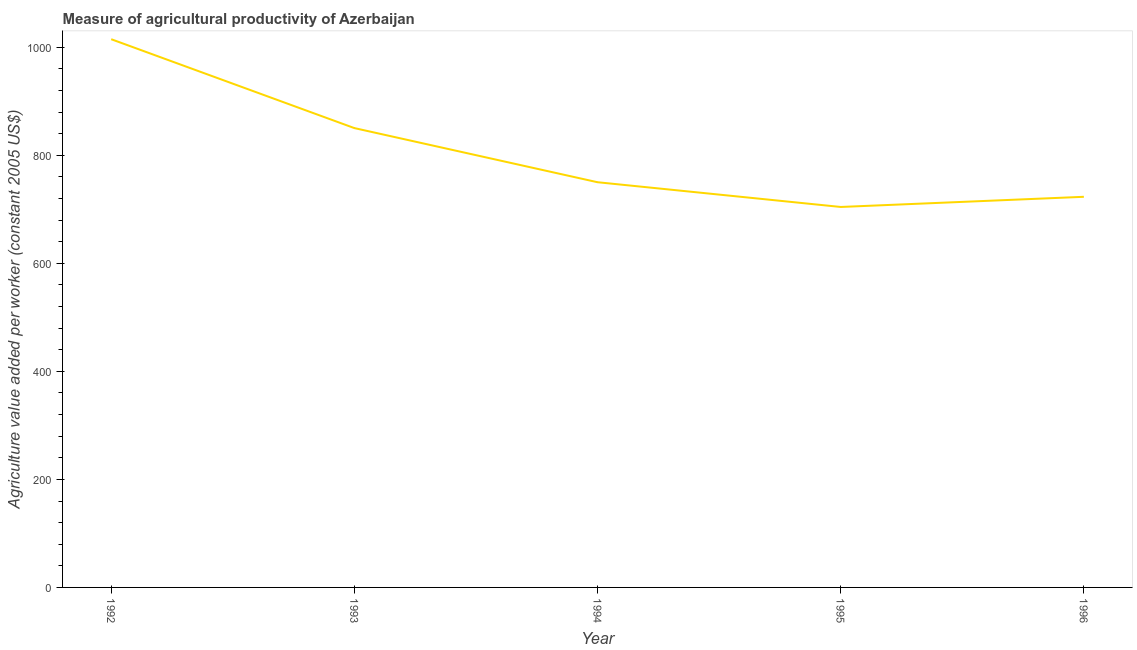What is the agriculture value added per worker in 1994?
Keep it short and to the point. 750.16. Across all years, what is the maximum agriculture value added per worker?
Offer a terse response. 1014.91. Across all years, what is the minimum agriculture value added per worker?
Make the answer very short. 704.35. What is the sum of the agriculture value added per worker?
Make the answer very short. 4042.96. What is the difference between the agriculture value added per worker in 1993 and 1995?
Your answer should be compact. 146.02. What is the average agriculture value added per worker per year?
Offer a terse response. 808.59. What is the median agriculture value added per worker?
Offer a terse response. 750.16. What is the ratio of the agriculture value added per worker in 1993 to that in 1996?
Provide a succinct answer. 1.18. What is the difference between the highest and the second highest agriculture value added per worker?
Ensure brevity in your answer.  164.54. Is the sum of the agriculture value added per worker in 1993 and 1995 greater than the maximum agriculture value added per worker across all years?
Ensure brevity in your answer.  Yes. What is the difference between the highest and the lowest agriculture value added per worker?
Provide a short and direct response. 310.56. In how many years, is the agriculture value added per worker greater than the average agriculture value added per worker taken over all years?
Offer a terse response. 2. Does the agriculture value added per worker monotonically increase over the years?
Keep it short and to the point. No. How many lines are there?
Make the answer very short. 1. Are the values on the major ticks of Y-axis written in scientific E-notation?
Give a very brief answer. No. Does the graph contain any zero values?
Give a very brief answer. No. Does the graph contain grids?
Your response must be concise. No. What is the title of the graph?
Provide a short and direct response. Measure of agricultural productivity of Azerbaijan. What is the label or title of the X-axis?
Keep it short and to the point. Year. What is the label or title of the Y-axis?
Your answer should be compact. Agriculture value added per worker (constant 2005 US$). What is the Agriculture value added per worker (constant 2005 US$) in 1992?
Your answer should be compact. 1014.91. What is the Agriculture value added per worker (constant 2005 US$) of 1993?
Give a very brief answer. 850.37. What is the Agriculture value added per worker (constant 2005 US$) of 1994?
Provide a succinct answer. 750.16. What is the Agriculture value added per worker (constant 2005 US$) in 1995?
Offer a terse response. 704.35. What is the Agriculture value added per worker (constant 2005 US$) in 1996?
Give a very brief answer. 723.17. What is the difference between the Agriculture value added per worker (constant 2005 US$) in 1992 and 1993?
Provide a succinct answer. 164.54. What is the difference between the Agriculture value added per worker (constant 2005 US$) in 1992 and 1994?
Make the answer very short. 264.76. What is the difference between the Agriculture value added per worker (constant 2005 US$) in 1992 and 1995?
Provide a succinct answer. 310.56. What is the difference between the Agriculture value added per worker (constant 2005 US$) in 1992 and 1996?
Your response must be concise. 291.75. What is the difference between the Agriculture value added per worker (constant 2005 US$) in 1993 and 1994?
Make the answer very short. 100.22. What is the difference between the Agriculture value added per worker (constant 2005 US$) in 1993 and 1995?
Your response must be concise. 146.02. What is the difference between the Agriculture value added per worker (constant 2005 US$) in 1993 and 1996?
Ensure brevity in your answer.  127.21. What is the difference between the Agriculture value added per worker (constant 2005 US$) in 1994 and 1995?
Give a very brief answer. 45.8. What is the difference between the Agriculture value added per worker (constant 2005 US$) in 1994 and 1996?
Provide a short and direct response. 26.99. What is the difference between the Agriculture value added per worker (constant 2005 US$) in 1995 and 1996?
Make the answer very short. -18.81. What is the ratio of the Agriculture value added per worker (constant 2005 US$) in 1992 to that in 1993?
Your response must be concise. 1.19. What is the ratio of the Agriculture value added per worker (constant 2005 US$) in 1992 to that in 1994?
Provide a succinct answer. 1.35. What is the ratio of the Agriculture value added per worker (constant 2005 US$) in 1992 to that in 1995?
Your response must be concise. 1.44. What is the ratio of the Agriculture value added per worker (constant 2005 US$) in 1992 to that in 1996?
Offer a very short reply. 1.4. What is the ratio of the Agriculture value added per worker (constant 2005 US$) in 1993 to that in 1994?
Offer a very short reply. 1.13. What is the ratio of the Agriculture value added per worker (constant 2005 US$) in 1993 to that in 1995?
Offer a terse response. 1.21. What is the ratio of the Agriculture value added per worker (constant 2005 US$) in 1993 to that in 1996?
Your answer should be very brief. 1.18. What is the ratio of the Agriculture value added per worker (constant 2005 US$) in 1994 to that in 1995?
Ensure brevity in your answer.  1.06. What is the ratio of the Agriculture value added per worker (constant 2005 US$) in 1994 to that in 1996?
Provide a succinct answer. 1.04. 